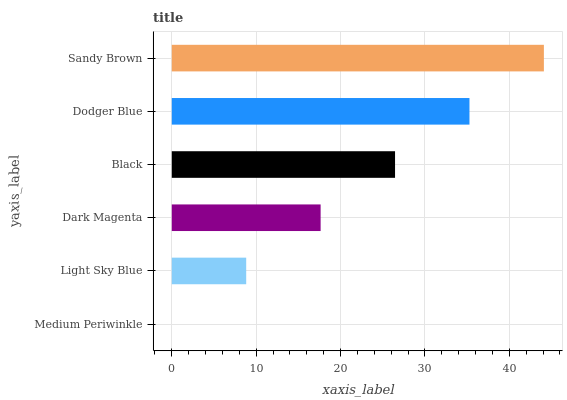Is Medium Periwinkle the minimum?
Answer yes or no. Yes. Is Sandy Brown the maximum?
Answer yes or no. Yes. Is Light Sky Blue the minimum?
Answer yes or no. No. Is Light Sky Blue the maximum?
Answer yes or no. No. Is Light Sky Blue greater than Medium Periwinkle?
Answer yes or no. Yes. Is Medium Periwinkle less than Light Sky Blue?
Answer yes or no. Yes. Is Medium Periwinkle greater than Light Sky Blue?
Answer yes or no. No. Is Light Sky Blue less than Medium Periwinkle?
Answer yes or no. No. Is Black the high median?
Answer yes or no. Yes. Is Dark Magenta the low median?
Answer yes or no. Yes. Is Medium Periwinkle the high median?
Answer yes or no. No. Is Dodger Blue the low median?
Answer yes or no. No. 